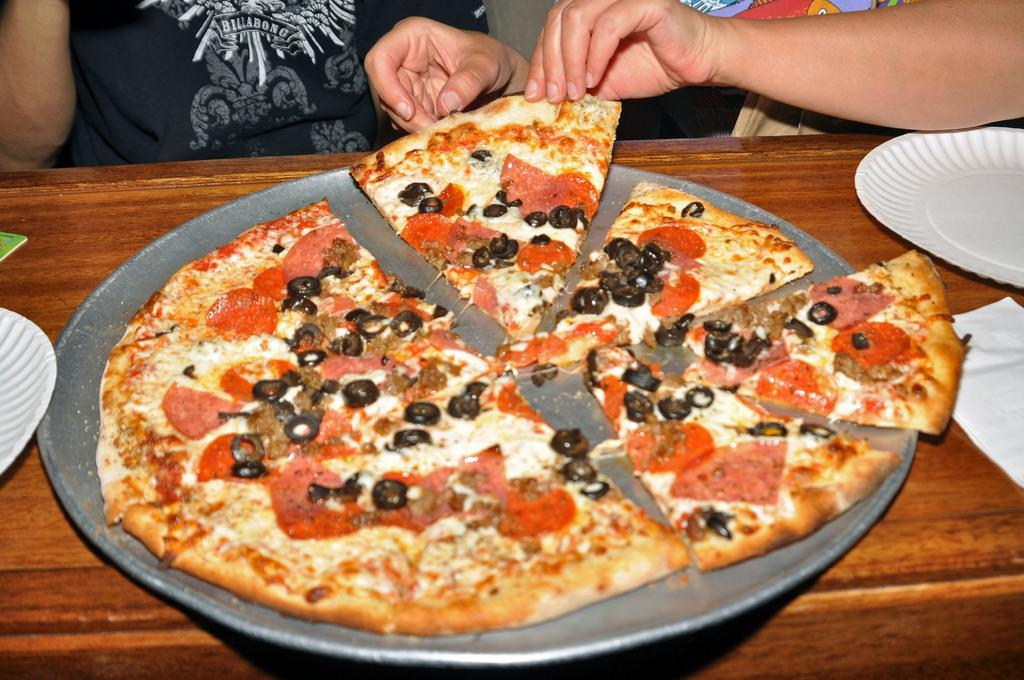What type of food is on the plate in the image? There is a pizza on a plate in the image. Where is the plate with the pizza located? The plate is placed on a table. Can you describe anything about the people in the background of the image? Yes, there are persons visible in the background of the image. What type of flower is growing on the pizza in the image? There is no flower present on the pizza in the image; it is a pizza with no additional toppings. 